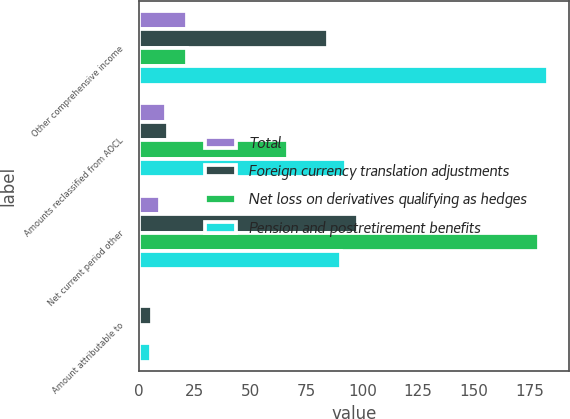Convert chart. <chart><loc_0><loc_0><loc_500><loc_500><stacked_bar_chart><ecel><fcel>Other comprehensive income<fcel>Amounts reclassified from AOCL<fcel>Net current period other<fcel>Amount attributable to<nl><fcel>Total<fcel>21.8<fcel>12.4<fcel>9.4<fcel>0.1<nl><fcel>Foreign currency translation adjustments<fcel>84.6<fcel>13.3<fcel>97.9<fcel>5.9<nl><fcel>Net loss on derivatives qualifying as hedges<fcel>21.8<fcel>67<fcel>179<fcel>0.2<nl><fcel>Pension and postretirement benefits<fcel>183.2<fcel>92.7<fcel>90.5<fcel>5.6<nl></chart> 